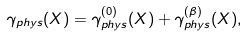Convert formula to latex. <formula><loc_0><loc_0><loc_500><loc_500>\gamma _ { p h y s } ( X ) = \gamma _ { p h y s } ^ { ( 0 ) } ( X ) + \gamma _ { p h y s } ^ { ( \beta ) } ( X ) ,</formula> 